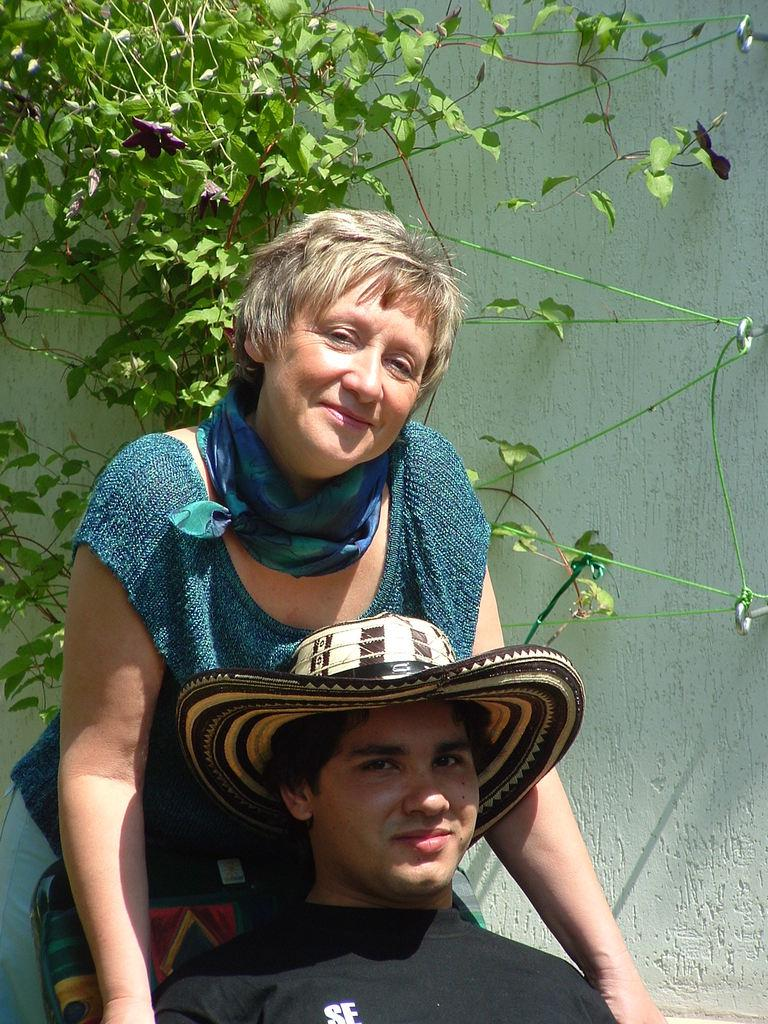What is the person in the image wearing? The person is wearing a black T-shirt in the image. What is the person doing in the image? The person is sitting in a chair. Who is present behind the person? There is a woman standing behind the person. What can be seen in the background of the image? There is a plant and a wall in the background of the image. What type of throat-soothing remedy is the person holding in the image? There is no throat-soothing remedy visible in the image. Can you tell me how many bikes are parked behind the person? There are no bikes present in the image. 